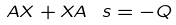<formula> <loc_0><loc_0><loc_500><loc_500>A X + X A \ s = - Q</formula> 